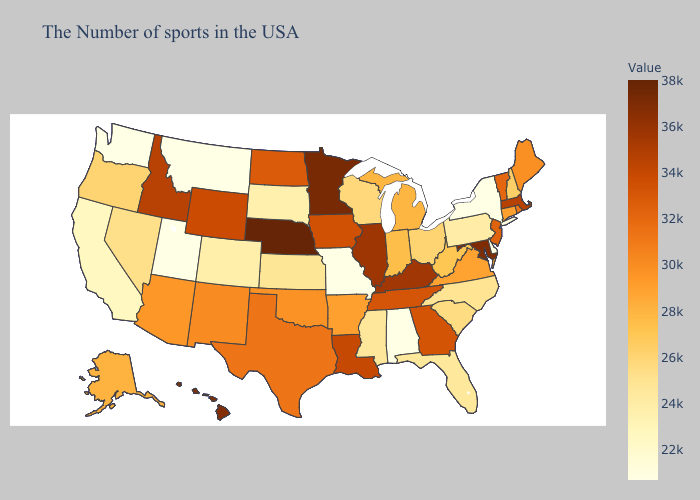Does Nebraska have the highest value in the USA?
Write a very short answer. Yes. Does Montana have the highest value in the USA?
Concise answer only. No. Among the states that border Colorado , which have the highest value?
Keep it brief. Nebraska. Among the states that border Maryland , which have the lowest value?
Give a very brief answer. Delaware. Does Minnesota have a lower value than Colorado?
Concise answer only. No. 